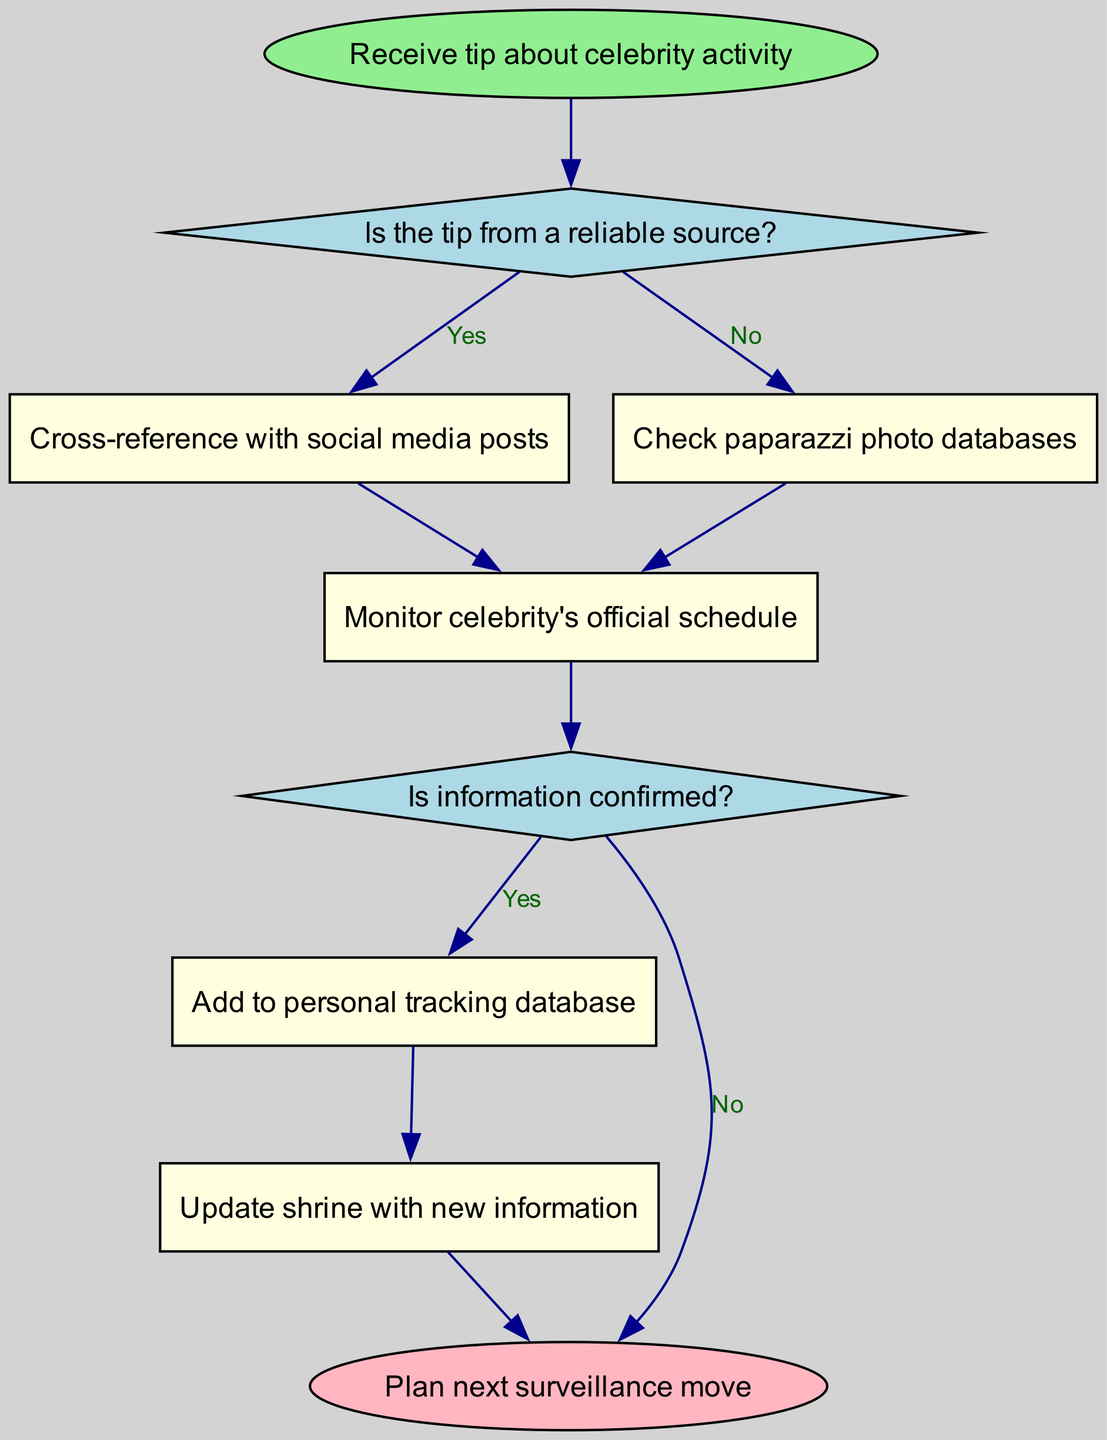What is the first step in the process? The first step in the flowchart is represented by the "start" node, which states "Receive tip about celebrity activity." This indicates the initiating action for the entire process.
Answer: Receive tip about celebrity activity How many actions follow Decision 1? After Decision 1, there are three action nodes: Cross-reference with social media posts, Check paparazzi photo databases, and Monitor celebrity's official schedule. Thus, the total is three actions.
Answer: Three What happens if the tip is not from a reliable source? If the tip is not from a reliable source, the flowchart branches to the action "Check paparazzi photo databases," which is an alternative route following the negative outcome of Decision 1.
Answer: Check paparazzi photo databases What is the outcome if the information is confirmed? If the information is confirmed (indicated by "Yes" in Decision 2), the next action is to "Add to personal tracking database," leading to updating the shrine.
Answer: Add to personal tracking database What is the final output of the process? The final output of the process is represented by the "end" node, which states "Plan next surveillance move." This indicates the conclusion of the current workflow and the transition to the next operational task.
Answer: Plan next surveillance move What occurs after checking social media posts? After checking social media posts, the flowchart leads to the action "Monitor celebrity's official schedule," indicating this as a subsequent step regardless of the decision from the first action.
Answer: Monitor celebrity's official schedule What occurs if the information is not confirmed? If the information is not confirmed, the flow continues directly to the "end" node, indicating that no further actions are taken and the process concludes.
Answer: End How many decision points are in this process? There are two decision points in the flowchart: the first one evaluates the reliability of the source, and the second one evaluates the confirmation of information. Thus, the total is two decision points.
Answer: Two 